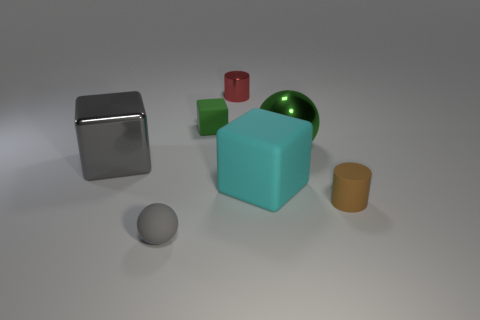Add 2 small green rubber objects. How many objects exist? 9 Subtract all cubes. How many objects are left? 4 Subtract 1 gray cubes. How many objects are left? 6 Subtract all large matte objects. Subtract all gray shiny cubes. How many objects are left? 5 Add 3 small metal objects. How many small metal objects are left? 4 Add 5 rubber objects. How many rubber objects exist? 9 